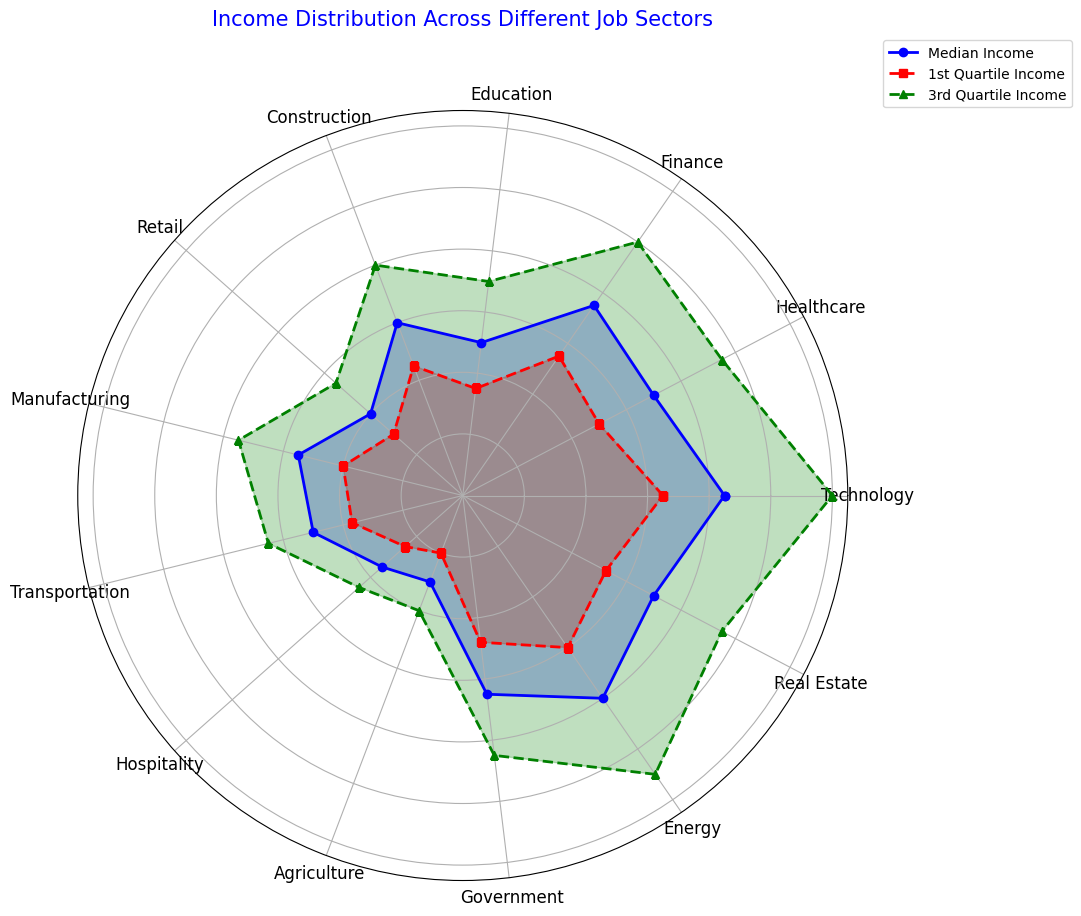Which job sector has the highest median income? By looking at the radar chart, the highest point of the blue line which represents the median income is at the "Technology" sector.
Answer: Technology Which job sector has the lowest 1st quartile income? The lowest point of the red dashed line which represents the 1st quartile income is at the "Agriculture" sector.
Answer: Agriculture Compare the median incomes of the Technology and Healthcare sectors. Which one is higher? By comparing the blue line points at "Technology" and "Healthcare" sectors, the median income in "Technology" sector is higher than in "Healthcare" sector.
Answer: Technology How does the 3rd quartile income in the Retail sector compare to the 1st quartile income in the Finance sector? The green dashed line at "Retail" sector is higher than the red dashed line at "Finance" sector, indicating that the 3rd quartile income in "Retail" is greater than the 1st quartile income in "Finance".
Answer: Retail What is the difference in the median income between the Government and Energy sectors? The blue points on the "Government" and "Energy" sectors show median incomes of 65000 and 80000 respectively. The difference is 80000 - 65000 = 15000.
Answer: 15000 In which job sector is the spread between the 1st and 3rd quartile incomes the greatest? The spread can be determined by the distance between the red and green dashed lines. Visually, the greatest spread is in the "Technology" sector.
Answer: Technology Which job sector has a higher 3rd quartile income, Manufacturing or Hospitality? By comparing the green points at "Manufacturing" and "Hospitality" sectors, "Manufacturing" has a higher 3rd quartile income than "Hospitality".
Answer: Manufacturing Is there any job sector where the median income is closer to the 1st quartile income than to the 3rd quartile income? By visually inspecting the blue, red, and green points, the "Retail" sector has the median income closer to the 1st quartile income than the 3rd quartile income.
Answer: Retail What is the ratio of median income between the Agriculture and Education sectors? The median incomes for "Agriculture" and "Education" are 30000 and 50000 respectively. The ratio is 30000 / 50000 = 0.6.
Answer: 0.6 